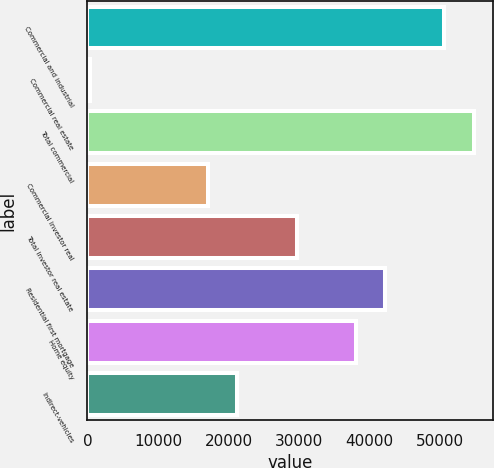Convert chart. <chart><loc_0><loc_0><loc_500><loc_500><bar_chart><fcel>Commercial and industrial<fcel>Commercial real estate<fcel>Total commercial<fcel>Commercial investor real<fcel>Total investor real estate<fcel>Residential first mortgage<fcel>Home equity<fcel>Indirect-vehicles<nl><fcel>50588.8<fcel>334<fcel>54776.7<fcel>17085.6<fcel>29649.3<fcel>42213<fcel>38025.1<fcel>21273.5<nl></chart> 